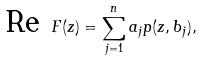<formula> <loc_0><loc_0><loc_500><loc_500>\text {Re } F ( z ) = \sum _ { j = 1 } ^ { n } a _ { j } p ( z , b _ { j } ) ,</formula> 